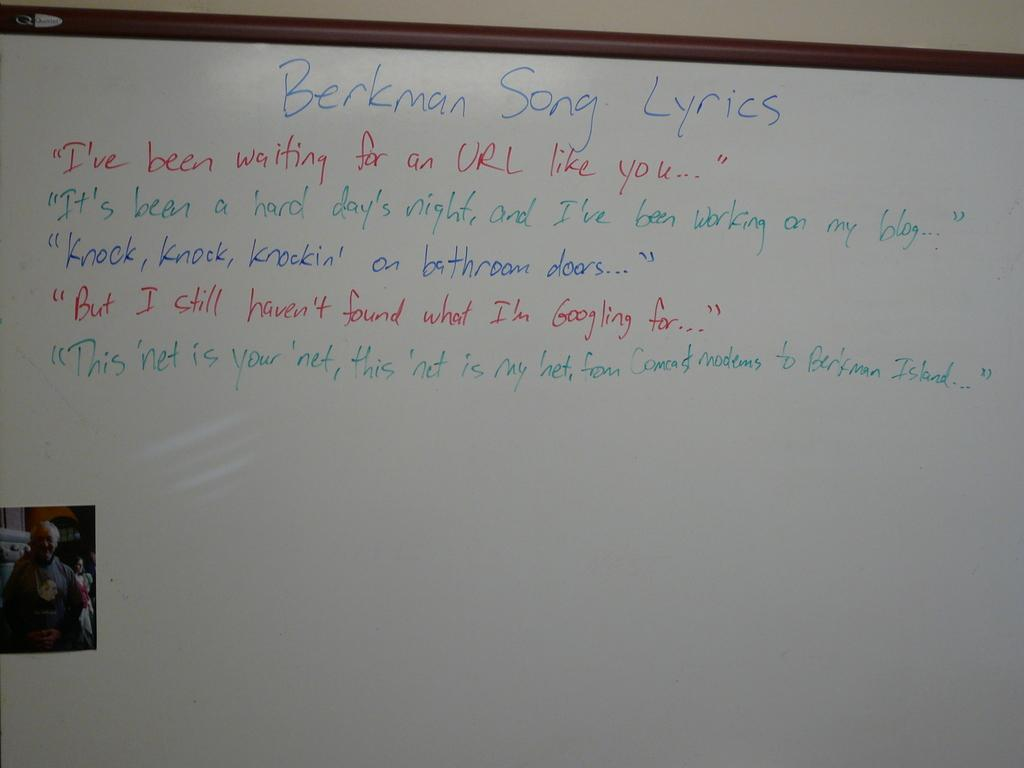<image>
Relay a brief, clear account of the picture shown. A whiteboard with Berkman Song lyrics in alternating lines of red, green and blue with a small photo of a man in the lower left corner. 